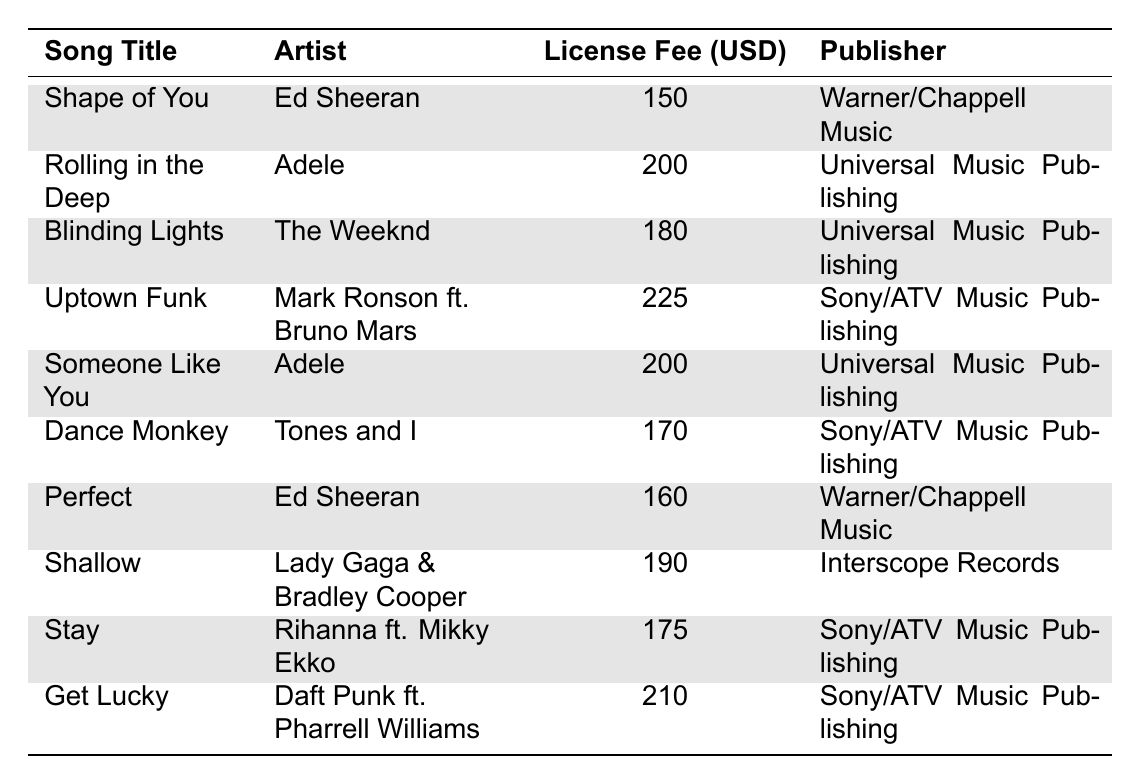What is the license fee for "Shape of You"? The table lists "Shape of You" by Ed Sheeran with a corresponding license fee of 150 USD.
Answer: 150 USD Which song has the highest license fee? Scanning the table, "Uptown Funk" by Mark Ronson ft. Bruno Mars has the highest license fee at 225 USD.
Answer: 225 USD What are the license fees for the songs by Adele? The table shows two songs by Adele: "Rolling in the Deep" and "Someone Like You," both with a license fee of 200 USD.
Answer: 200 USD Is "Perfect" more expensive than "Dance Monkey"? The license fee for "Perfect" is 160 USD, while "Dance Monkey" is 170 USD. Since 160 is less than 170, "Perfect" is not more expensive than "Dance Monkey."
Answer: No What is the total license fee for all songs by Ed Sheeran? Ed Sheeran's songs are "Shape of You" (150 USD) and "Perfect" (160 USD). Adding these gives 150 + 160 = 310 USD.
Answer: 310 USD Calculate the average license fee for songs published by Sony/ATV Music Publishing. The songs from Sony/ATV are "Uptown Funk" (225 USD), "Dance Monkey" (170 USD), "Stay" (175 USD), and "Get Lucky" (210 USD). The total fee is 225 + 170 + 175 + 210 = 780 USD. There are 4 songs, so the average is 780 / 4 = 195 USD.
Answer: 195 USD Are there any songs with a license fee of 200 USD? Yes, the table lists two songs with a license fee of 200 USD: "Rolling in the Deep" and "Someone Like You."
Answer: Yes What is the difference in license fees between "Blinding Lights" and "Stay"? "Blinding Lights" costs 180 USD, and "Stay" costs 175 USD. The difference is calculated as 180 - 175 = 5 USD.
Answer: 5 USD Which publisher has the most songs listed? The table shows both Universal Music Publishing and Sony/ATV Music Publishing have the same number of songs, two each. Thus, there is no single publisher with the most songs; they are tied.
Answer: None, they are tied What is the license fee for "Get Lucky" and which artist performed it? "Get Lucky" has a license fee of 210 USD and is performed by Daft Punk ft. Pharrell Williams.
Answer: 210 USD, Daft Punk ft. Pharrell Williams 